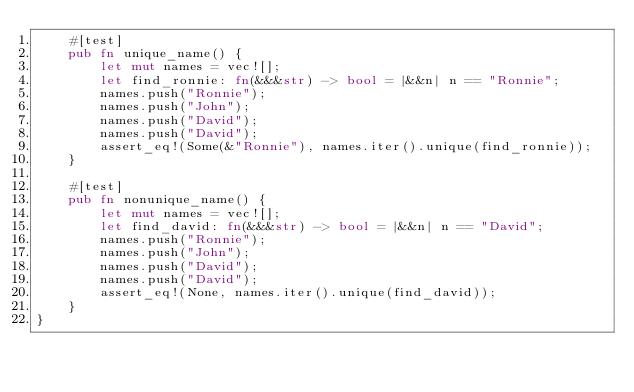<code> <loc_0><loc_0><loc_500><loc_500><_Rust_>    #[test]
    pub fn unique_name() {
        let mut names = vec![];
        let find_ronnie: fn(&&&str) -> bool = |&&n| n == "Ronnie";
        names.push("Ronnie");
        names.push("John");
        names.push("David");
        names.push("David");
        assert_eq!(Some(&"Ronnie"), names.iter().unique(find_ronnie));
    }

    #[test]
    pub fn nonunique_name() {
        let mut names = vec![];
        let find_david: fn(&&&str) -> bool = |&&n| n == "David";
        names.push("Ronnie");
        names.push("John");
        names.push("David");
        names.push("David");
        assert_eq!(None, names.iter().unique(find_david));
    }
}
</code> 